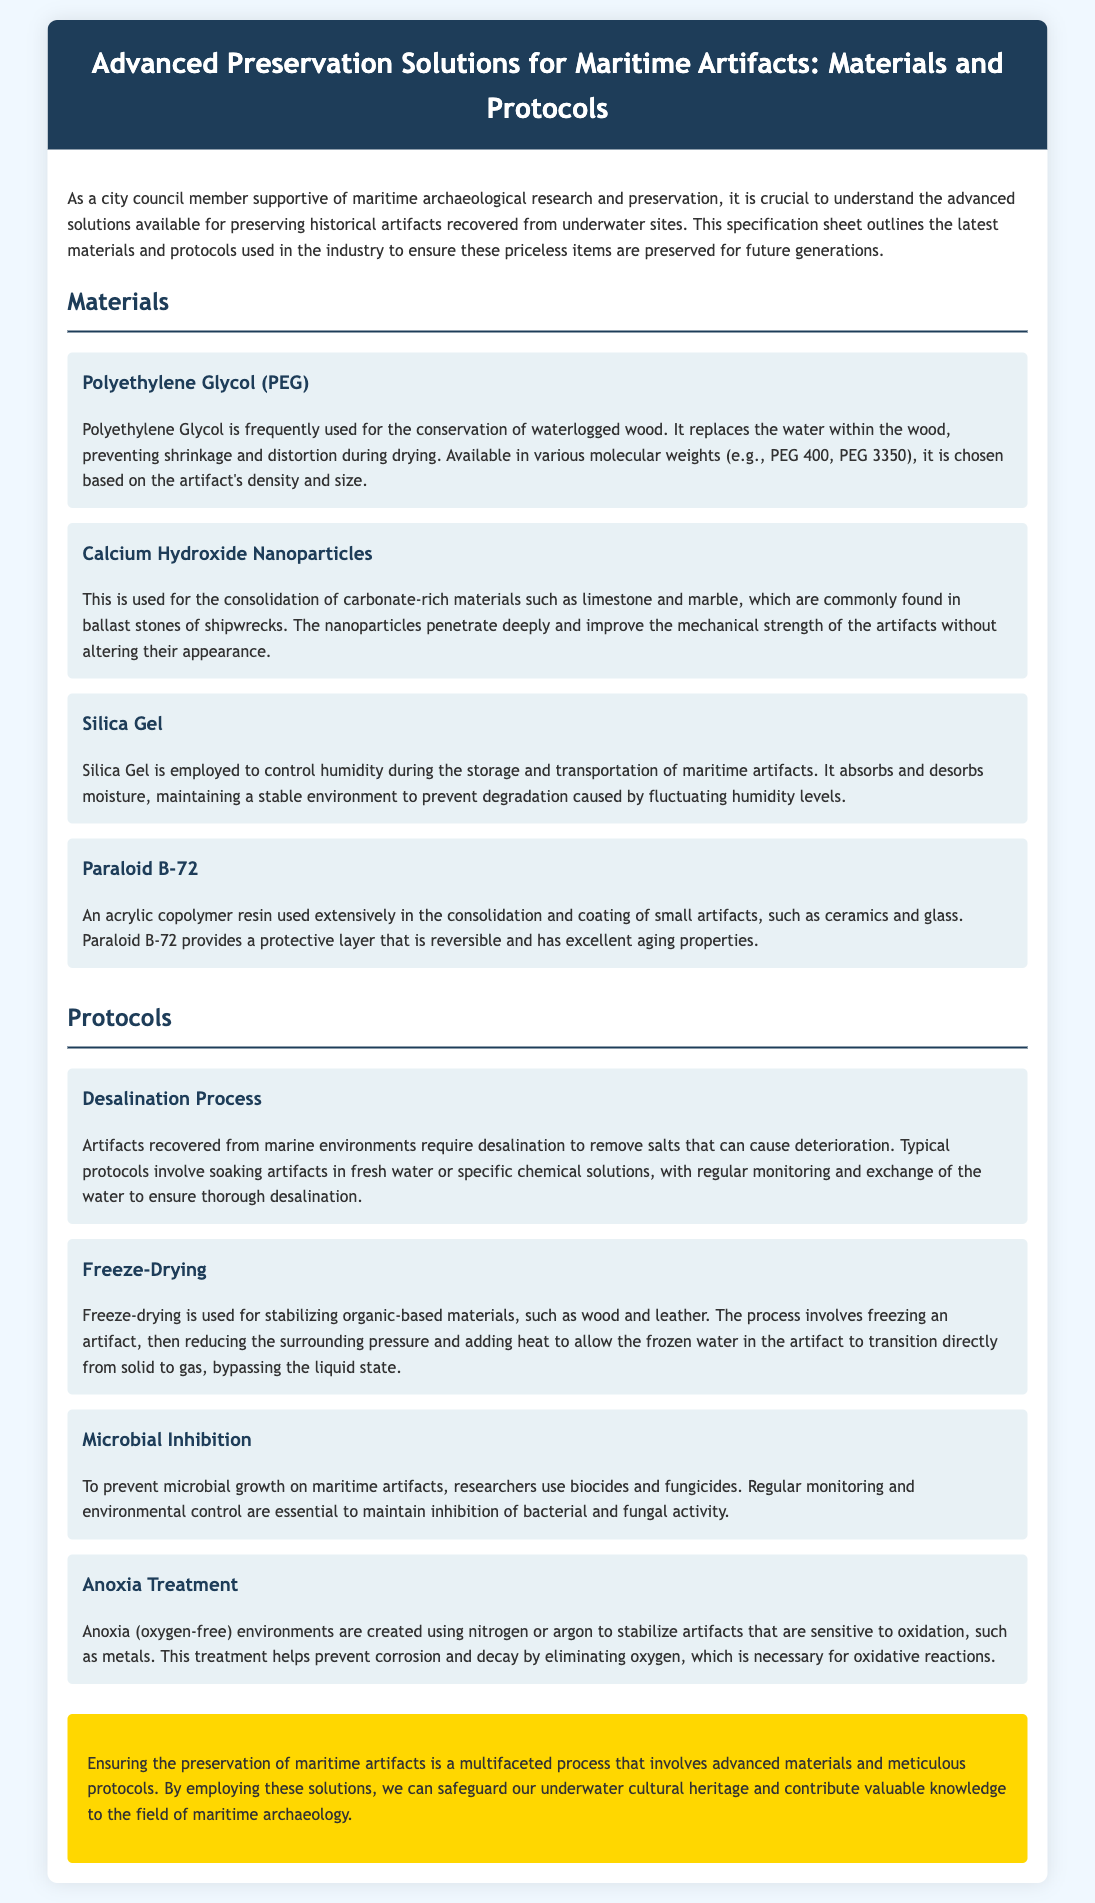what is the primary material used for the conservation of waterlogged wood? The document states that Polyethylene Glycol is frequently used for this purpose.
Answer: Polyethylene Glycol which nanoparticle is used for consolidating carbonate-rich materials? The document mentions Calcium Hydroxide Nanoparticles for this purpose.
Answer: Calcium Hydroxide Nanoparticles what protocol involves soaking artifacts in fresh water? The process described for removing salts from artifacts is called Desalination Process.
Answer: Desalination Process what is the purpose of utilizing Silica Gel in artifact preservation? The document explains that Silica Gel is employed to control humidity during storage and transportation.
Answer: Control humidity which treatment creates an oxygen-free environment to stabilize sensitive artifacts? The document refers to Anoxia Treatment for creating such environments.
Answer: Anoxia Treatment how does freeze-drying help preserve organic materials? The document describes that freeze-drying stabilizes materials by allowing frozen water to transition directly from solid to gas.
Answer: Stabilizing materials what is one method mentioned to prevent microbial growth? The document explains that biocides and fungicides are used as one method for prevention.
Answer: Biocides and fungicides which material provides a reversible protective layer for small artifacts? The document mentions Paraloid B-72 as an acrylic copolymer resin for this purpose.
Answer: Paraloid B-72 